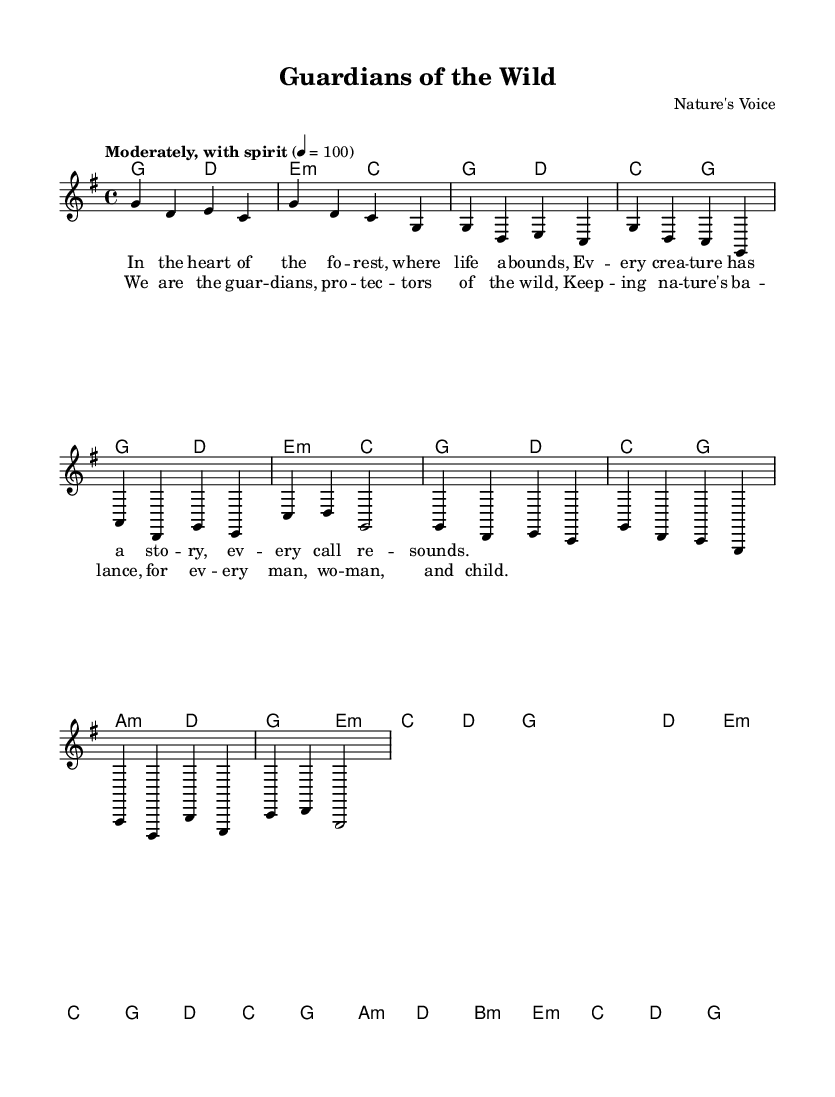What is the key signature of this music? The key signature is G major, which has one sharp (F#) as indicated by the key signature notation.
Answer: G major What is the time signature of this music? The time signature shown is 4/4, which indicates there are four beats per measure, and the quarter note gets one beat.
Answer: 4/4 What is the tempo marking of this music? The tempo marking states "Moderately, with spirit," and specifies a beats per minute speed of 100, indicating how fast the music should be played.
Answer: Moderately, with spirit How many measures are in the chorus? The chorus includes a total of four measures, which can be counted by looking at the measure lines provided in the sheet music.
Answer: Four measures What is the first line of the verse lyrics? The first line of the verse is presented in the lyrics section and reads "In the heart of the fo -- rest, where life a -- bounds," indicating the opening theme of the song.
Answer: In the heart of the fo -- rest, where life a -- bounds Which chord follows the A minor chord in the verse? By examining the harmonies, the A minor chord is followed by the D chord, which is part of the corresponding harmonic progression in the verse section.
Answer: D What do the lyrics in the chorus highlight? The lyrics in the chorus emphasize the theme of guardianship and protection of nature, showing the collective responsibility towards wildlife and conservation.
Answer: Guardianship and protection 